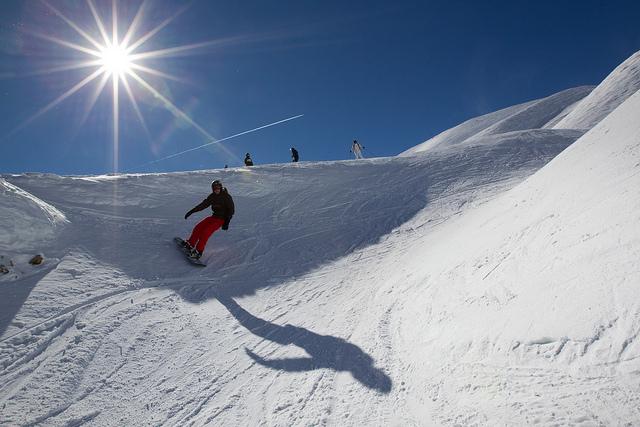Is the man on air?
Quick response, please. No. What time of day is the picture taken?
Short answer required. Afternoon. What sport is this?
Be succinct. Snowboarding. What is the person holding in each hand?
Write a very short answer. Nothing. What is this person doing?
Quick response, please. Snowboarding. Is the snowboarding jumping high?
Be succinct. No. Are there clouds in the sky?
Be succinct. No. What kind of competition is this?
Keep it brief. Snowboarding. What color is the snowboard?
Answer briefly. Black. What is the viscosity of the snow?
Quick response, please. Packed. Has the ski slope been groomed recently?
Concise answer only. Yes. How many snowboarders are in the picture?
Write a very short answer. 1. What sport are these people participating in?
Concise answer only. Snowboarding. Is this ski jump manmade?
Write a very short answer. No. Has the ski slope been groomed?
Short answer required. Yes. What is the person wearing on their head?
Write a very short answer. Hat. What number of men are riding a snowboard?
Be succinct. 1. Is this a time lapse photo?
Give a very brief answer. No. Can you see the shadow of the snowboarder?
Give a very brief answer. Yes. Is it a cloudy day?
Short answer required. No. What are the people doing?
Be succinct. Snowboarding. Is this person wearing a helmet?
Be succinct. Yes. 